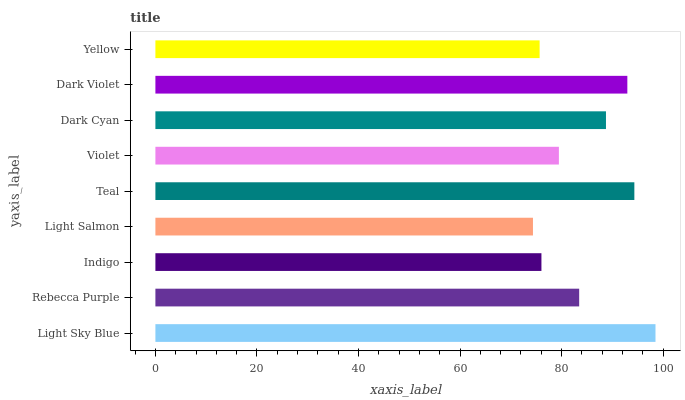Is Light Salmon the minimum?
Answer yes or no. Yes. Is Light Sky Blue the maximum?
Answer yes or no. Yes. Is Rebecca Purple the minimum?
Answer yes or no. No. Is Rebecca Purple the maximum?
Answer yes or no. No. Is Light Sky Blue greater than Rebecca Purple?
Answer yes or no. Yes. Is Rebecca Purple less than Light Sky Blue?
Answer yes or no. Yes. Is Rebecca Purple greater than Light Sky Blue?
Answer yes or no. No. Is Light Sky Blue less than Rebecca Purple?
Answer yes or no. No. Is Rebecca Purple the high median?
Answer yes or no. Yes. Is Rebecca Purple the low median?
Answer yes or no. Yes. Is Light Salmon the high median?
Answer yes or no. No. Is Light Salmon the low median?
Answer yes or no. No. 